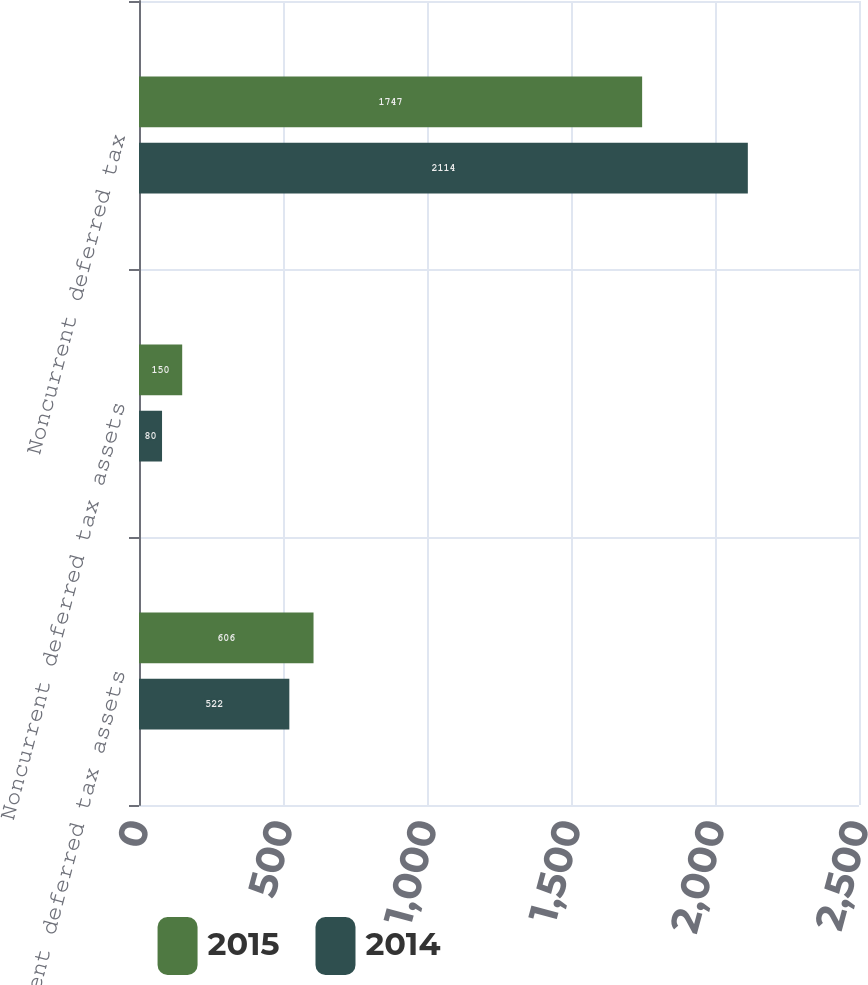Convert chart to OTSL. <chart><loc_0><loc_0><loc_500><loc_500><stacked_bar_chart><ecel><fcel>Current deferred tax assets<fcel>Noncurrent deferred tax assets<fcel>Noncurrent deferred tax<nl><fcel>2015<fcel>606<fcel>150<fcel>1747<nl><fcel>2014<fcel>522<fcel>80<fcel>2114<nl></chart> 